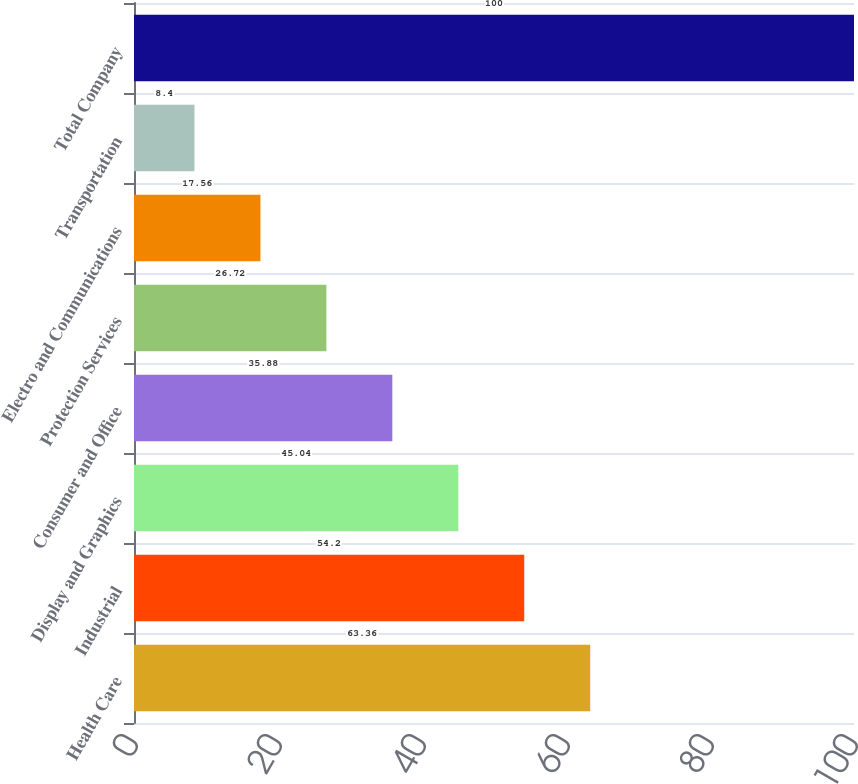<chart> <loc_0><loc_0><loc_500><loc_500><bar_chart><fcel>Health Care<fcel>Industrial<fcel>Display and Graphics<fcel>Consumer and Office<fcel>Protection Services<fcel>Electro and Communications<fcel>Transportation<fcel>Total Company<nl><fcel>63.36<fcel>54.2<fcel>45.04<fcel>35.88<fcel>26.72<fcel>17.56<fcel>8.4<fcel>100<nl></chart> 